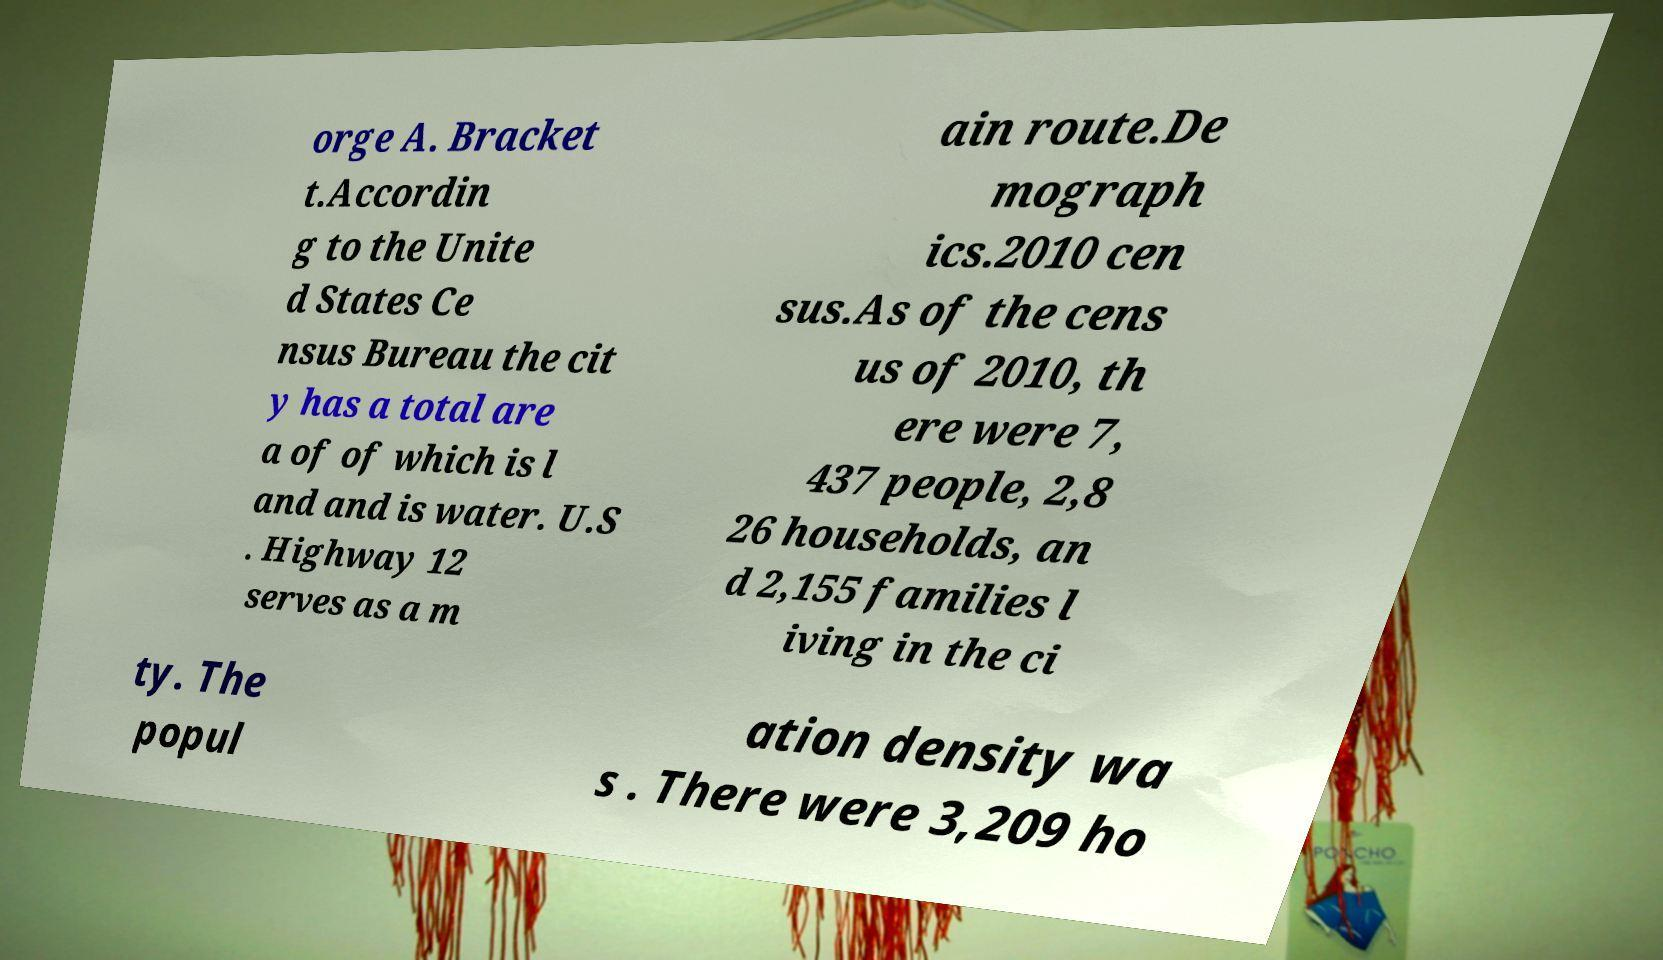For documentation purposes, I need the text within this image transcribed. Could you provide that? orge A. Bracket t.Accordin g to the Unite d States Ce nsus Bureau the cit y has a total are a of of which is l and and is water. U.S . Highway 12 serves as a m ain route.De mograph ics.2010 cen sus.As of the cens us of 2010, th ere were 7, 437 people, 2,8 26 households, an d 2,155 families l iving in the ci ty. The popul ation density wa s . There were 3,209 ho 